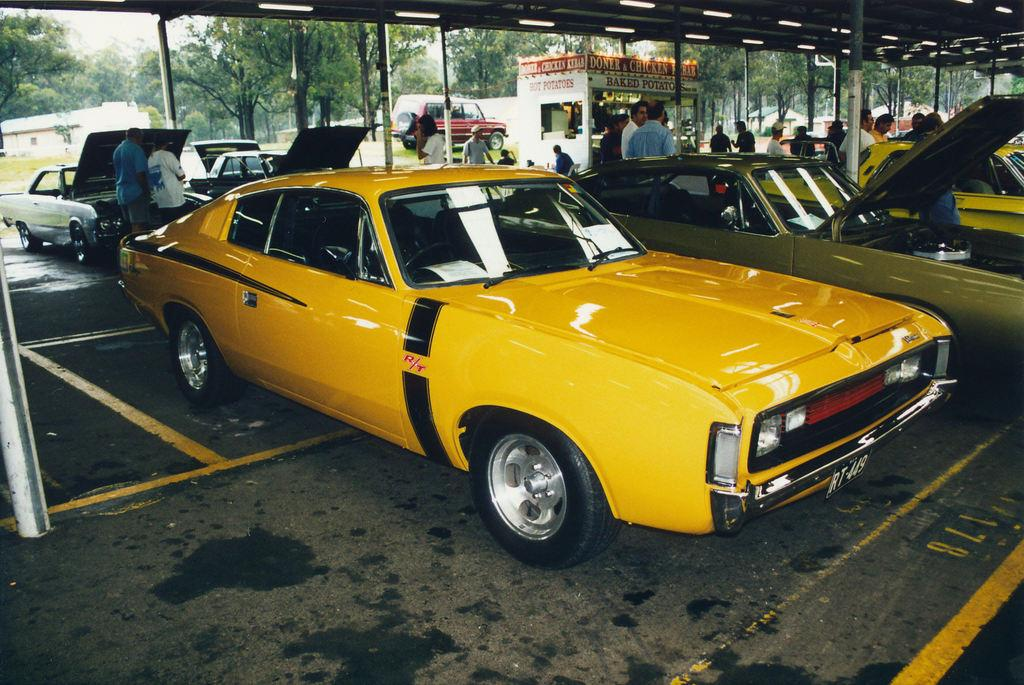<image>
Give a short and clear explanation of the subsequent image. A booth selling baked potato is behind classic cars on display in a parking lot. 